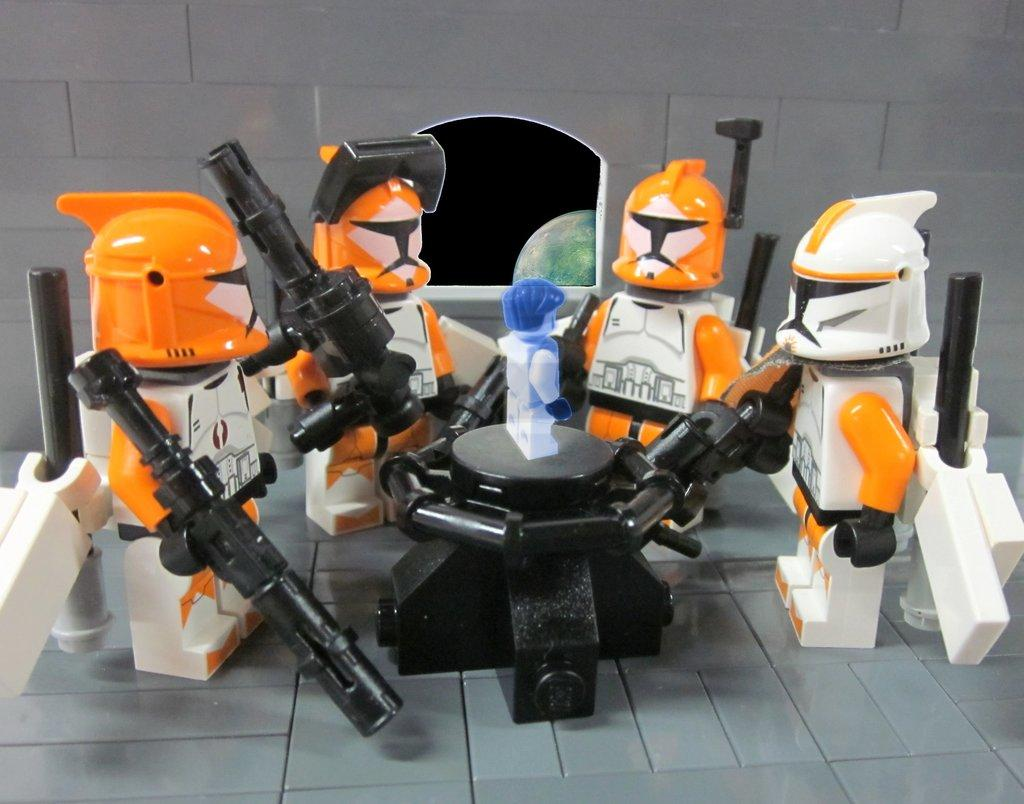What is on the floor in the image? There are toys on the floor, and there is an object on the floor. Can you describe the astronomical object visible in the background? Unfortunately, the provided facts do not specify the type of astronomical object visible in the background. What is present in the background of the image? There is a wall in the background of the image. What type of jar can be seen on the wall in the image? There is no jar present on the wall in the image. What type of amusement can be seen in the image? The provided facts do not mention any amusement in the image. What design elements are present in the image? The provided facts do not mention any specific design elements in the image. 